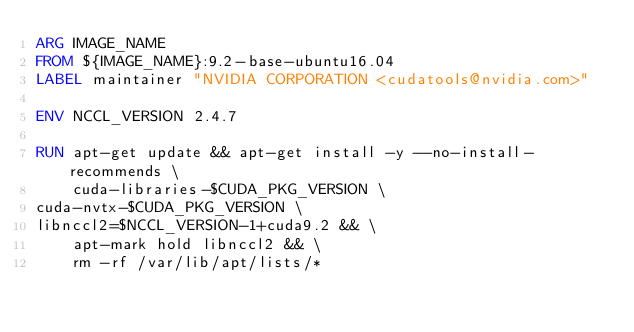Convert code to text. <code><loc_0><loc_0><loc_500><loc_500><_Dockerfile_>ARG IMAGE_NAME
FROM ${IMAGE_NAME}:9.2-base-ubuntu16.04
LABEL maintainer "NVIDIA CORPORATION <cudatools@nvidia.com>"

ENV NCCL_VERSION 2.4.7

RUN apt-get update && apt-get install -y --no-install-recommends \
    cuda-libraries-$CUDA_PKG_VERSION \
cuda-nvtx-$CUDA_PKG_VERSION \
libnccl2=$NCCL_VERSION-1+cuda9.2 && \
    apt-mark hold libnccl2 && \
    rm -rf /var/lib/apt/lists/*</code> 